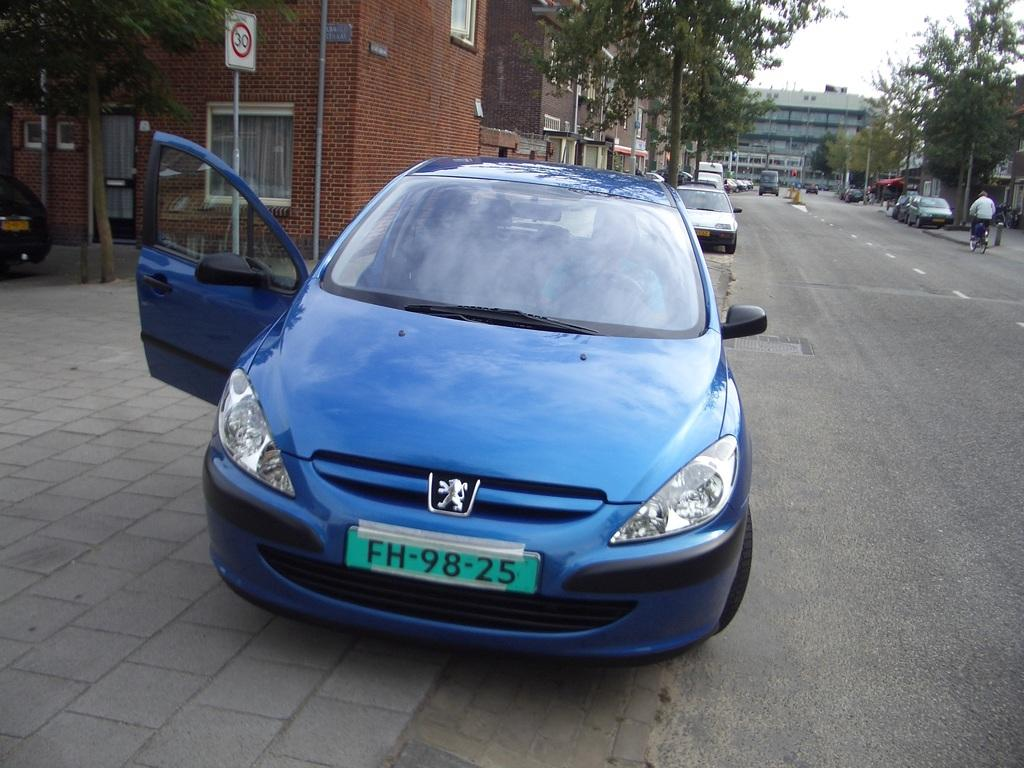<image>
Share a concise interpretation of the image provided. A blue car with a license plate that begins with FH. 